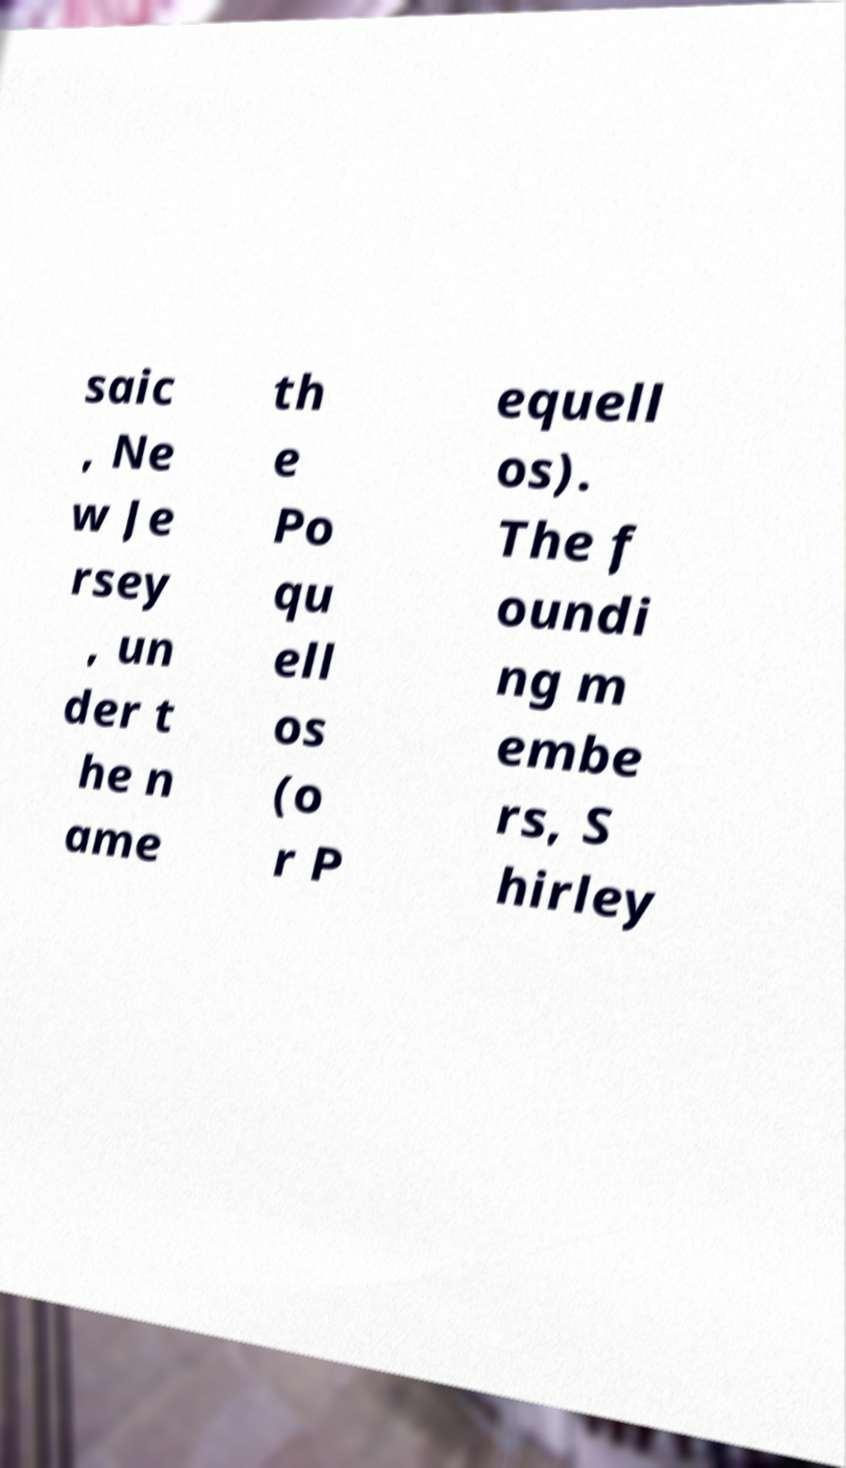Can you read and provide the text displayed in the image?This photo seems to have some interesting text. Can you extract and type it out for me? saic , Ne w Je rsey , un der t he n ame th e Po qu ell os (o r P equell os). The f oundi ng m embe rs, S hirley 